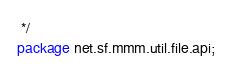Convert code to text. <code><loc_0><loc_0><loc_500><loc_500><_Java_> */
package net.sf.mmm.util.file.api;
</code> 